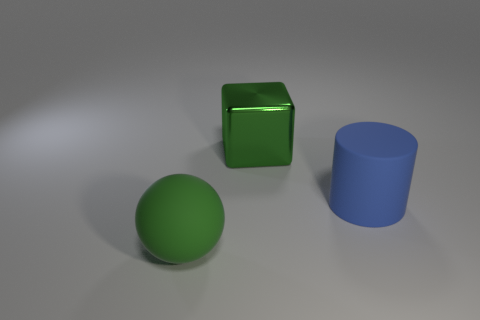There is a green object that is on the left side of the cube; is its size the same as the object right of the metallic object?
Keep it short and to the point. Yes. What is the material of the thing that is both on the left side of the blue matte cylinder and in front of the green shiny block?
Provide a short and direct response. Rubber. Are there any other things that have the same color as the metallic object?
Your response must be concise. Yes. Is the number of metal blocks behind the large green metal thing less than the number of large blue objects?
Offer a very short reply. Yes. Is the number of small green metallic balls greater than the number of matte balls?
Give a very brief answer. No. Is there a large rubber object in front of the big matte thing left of the big green object behind the big green rubber thing?
Keep it short and to the point. No. There is a green metallic cube; are there any big balls to the right of it?
Make the answer very short. No. Do the rubber cylinder and the object that is to the left of the big metal block have the same color?
Offer a terse response. No. There is a rubber thing on the left side of the rubber thing behind the green thing to the left of the green cube; what color is it?
Your answer should be very brief. Green. Are there any large blue things that have the same shape as the green rubber object?
Your answer should be very brief. No. 